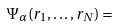Convert formula to latex. <formula><loc_0><loc_0><loc_500><loc_500>\Psi _ { \alpha } ( { r _ { 1 } , \dots , r _ { N } } ) =</formula> 